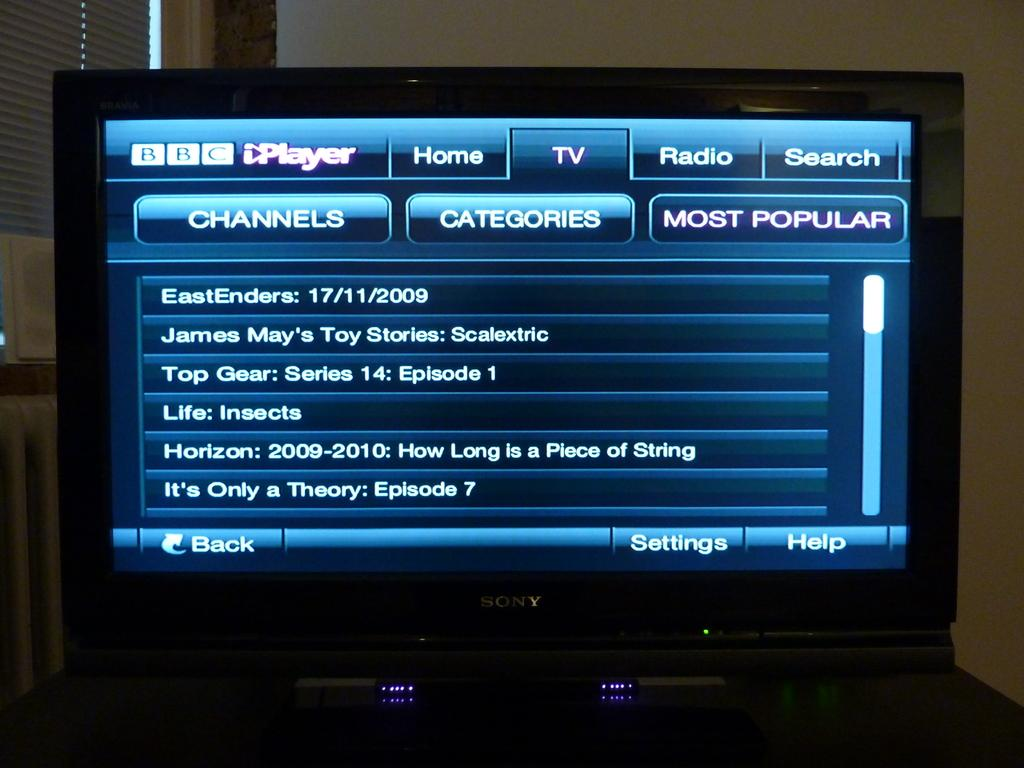<image>
Render a clear and concise summary of the photo. The Sony TV has the BBC Channels showing on the screen. 